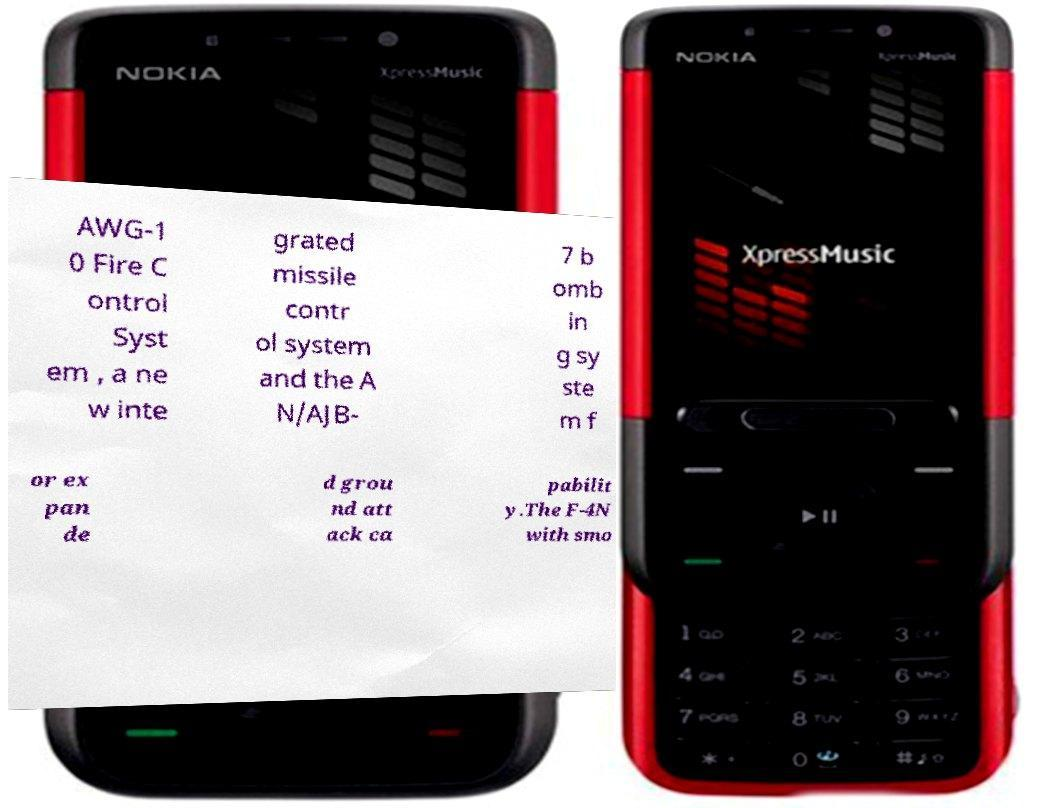What messages or text are displayed in this image? I need them in a readable, typed format. AWG-1 0 Fire C ontrol Syst em , a ne w inte grated missile contr ol system and the A N/AJB- 7 b omb in g sy ste m f or ex pan de d grou nd att ack ca pabilit y.The F-4N with smo 